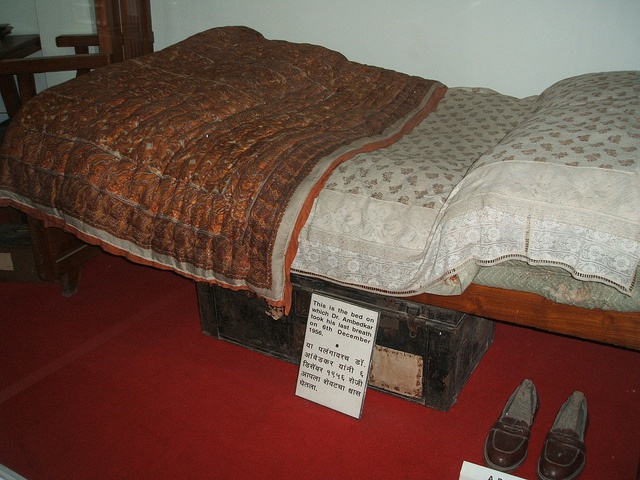Describe the objects in this image and their specific colors. I can see bed in gray, maroon, darkgray, and black tones, suitcase in gray, black, and maroon tones, and chair in gray, black, and maroon tones in this image. 